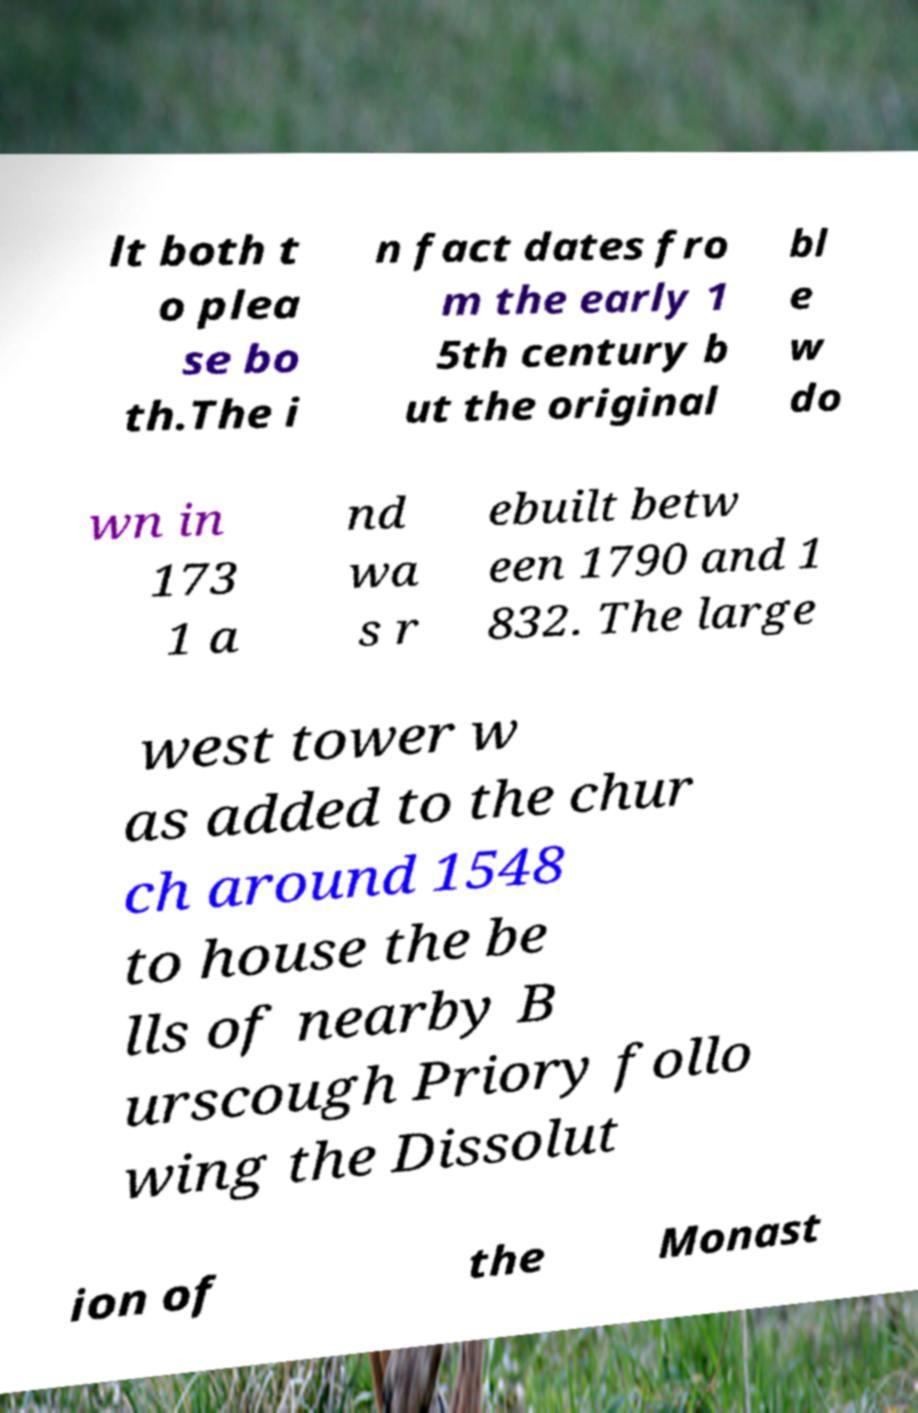Can you read and provide the text displayed in the image?This photo seems to have some interesting text. Can you extract and type it out for me? lt both t o plea se bo th.The i n fact dates fro m the early 1 5th century b ut the original bl e w do wn in 173 1 a nd wa s r ebuilt betw een 1790 and 1 832. The large west tower w as added to the chur ch around 1548 to house the be lls of nearby B urscough Priory follo wing the Dissolut ion of the Monast 